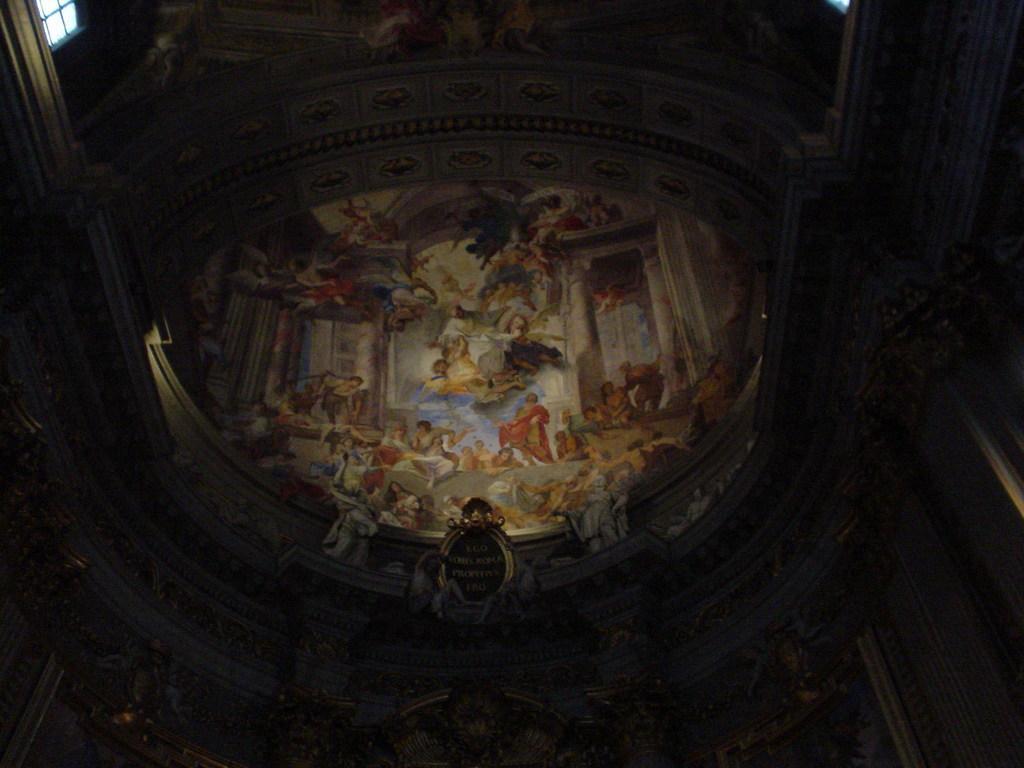Can you describe this image briefly? In this picture there are few images on the interior walls of a building. 